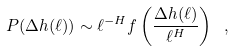<formula> <loc_0><loc_0><loc_500><loc_500>P ( \Delta h ( \ell ) ) \sim \ell ^ { - H } f \left ( \frac { \Delta h ( \ell ) } { \ell ^ { H } } \right ) \ ,</formula> 